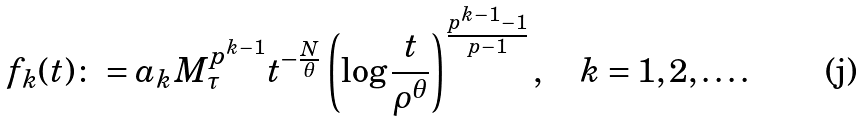<formula> <loc_0><loc_0><loc_500><loc_500>f _ { k } ( t ) \colon = a _ { k } M _ { \tau } ^ { p ^ { k - 1 } } t ^ { - \frac { N } { \theta } } \left ( \log \frac { t } { \rho ^ { \theta } } \right ) ^ { \frac { p ^ { k - 1 } - 1 } { p - 1 } } , \quad k = 1 , 2 , \dots .</formula> 